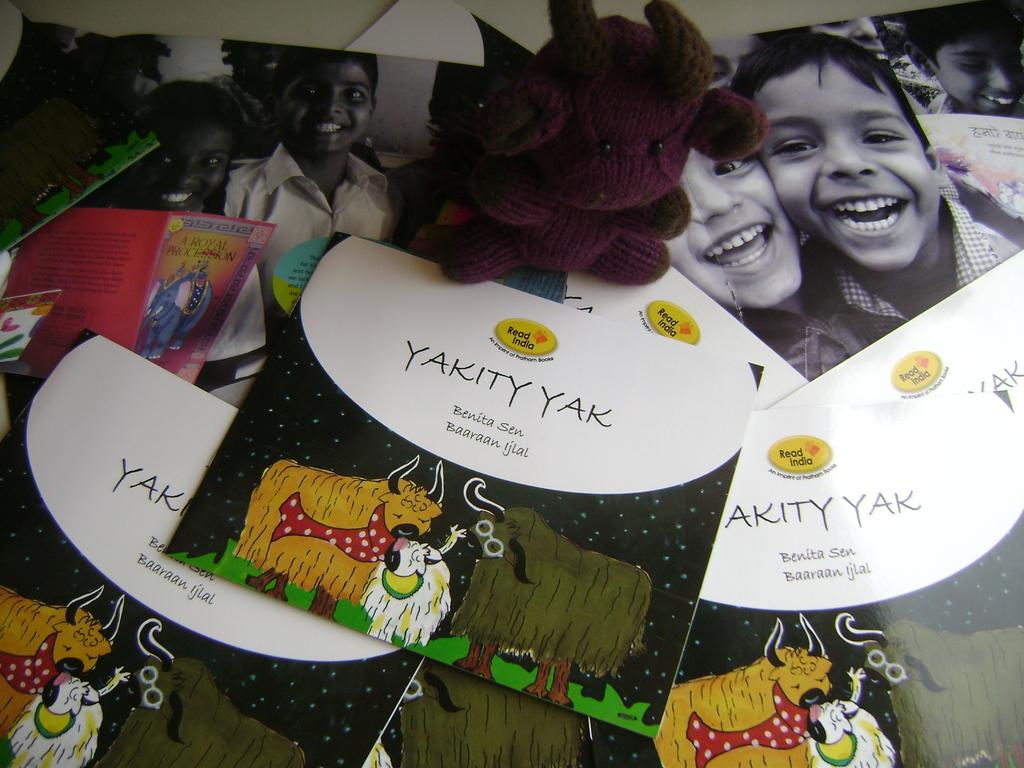What items are present in the image that are related to communication or celebration? There are greeting cards in the image. What other items can be seen in the image? There are photos in the image. What is the color of the table in the image? The table is white. What type of object is on the table and has a purple color? There is a purple color stuffed toy on the table. What type of toothpaste is being used by the crook in the image? There is no crook or toothpaste present in the image. 